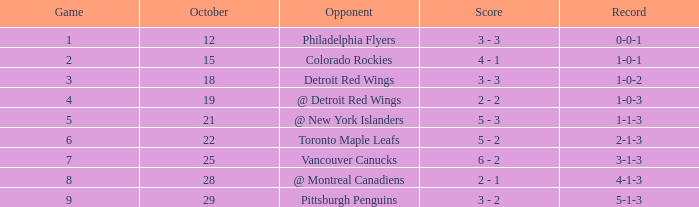Specify the score for a game over 6 and preceding october 2 6 - 2. 